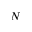<formula> <loc_0><loc_0><loc_500><loc_500>N</formula> 